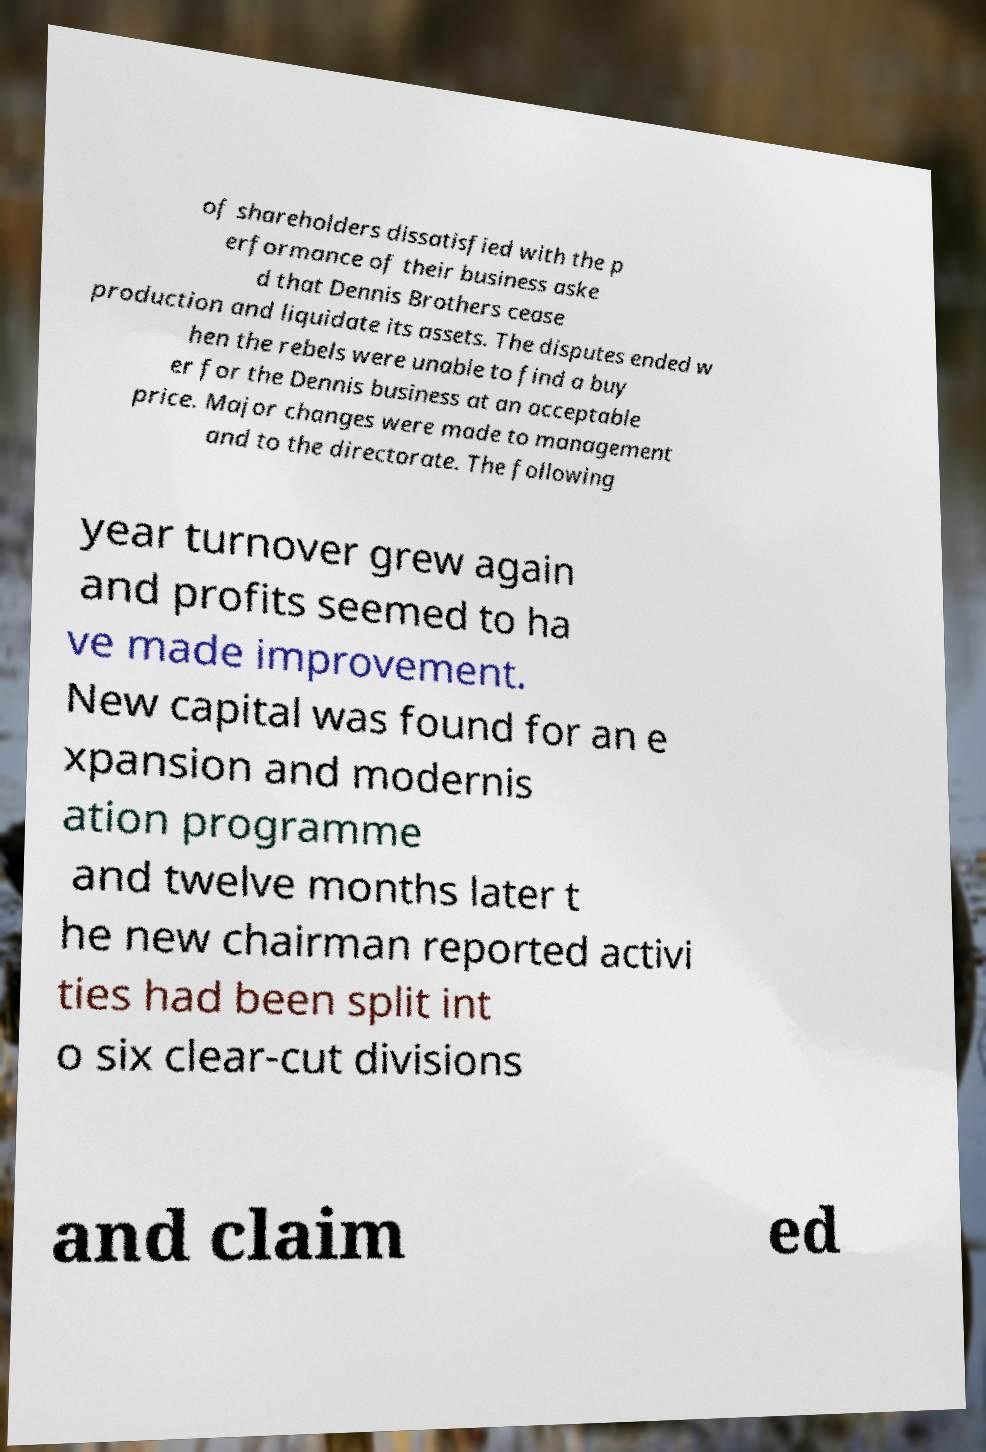There's text embedded in this image that I need extracted. Can you transcribe it verbatim? of shareholders dissatisfied with the p erformance of their business aske d that Dennis Brothers cease production and liquidate its assets. The disputes ended w hen the rebels were unable to find a buy er for the Dennis business at an acceptable price. Major changes were made to management and to the directorate. The following year turnover grew again and profits seemed to ha ve made improvement. New capital was found for an e xpansion and modernis ation programme and twelve months later t he new chairman reported activi ties had been split int o six clear-cut divisions and claim ed 